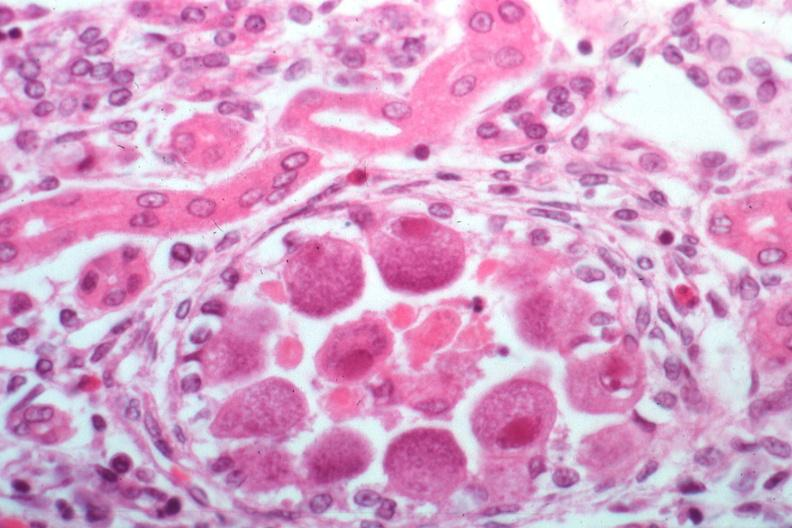s kidney present?
Answer the question using a single word or phrase. Yes 